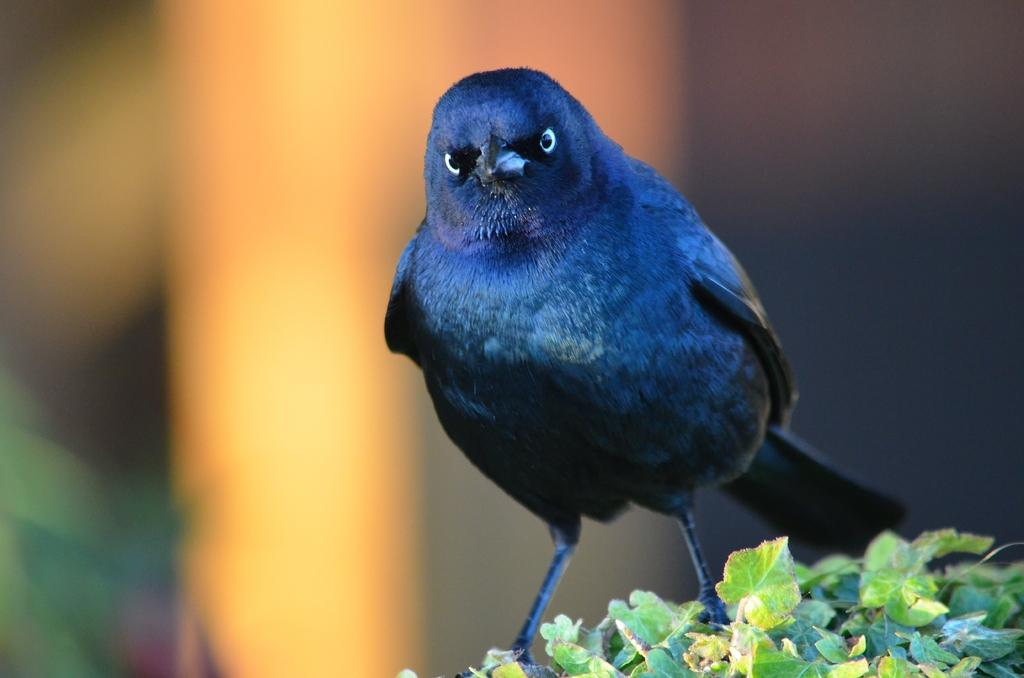What type of animal can be seen in the image? There is a bird in the image. What is the bird standing on? The bird is standing on creepers. What type of butter is being used to draw a line on the bird's wings in the image? There is no butter or line present on the bird's wings in the image. 